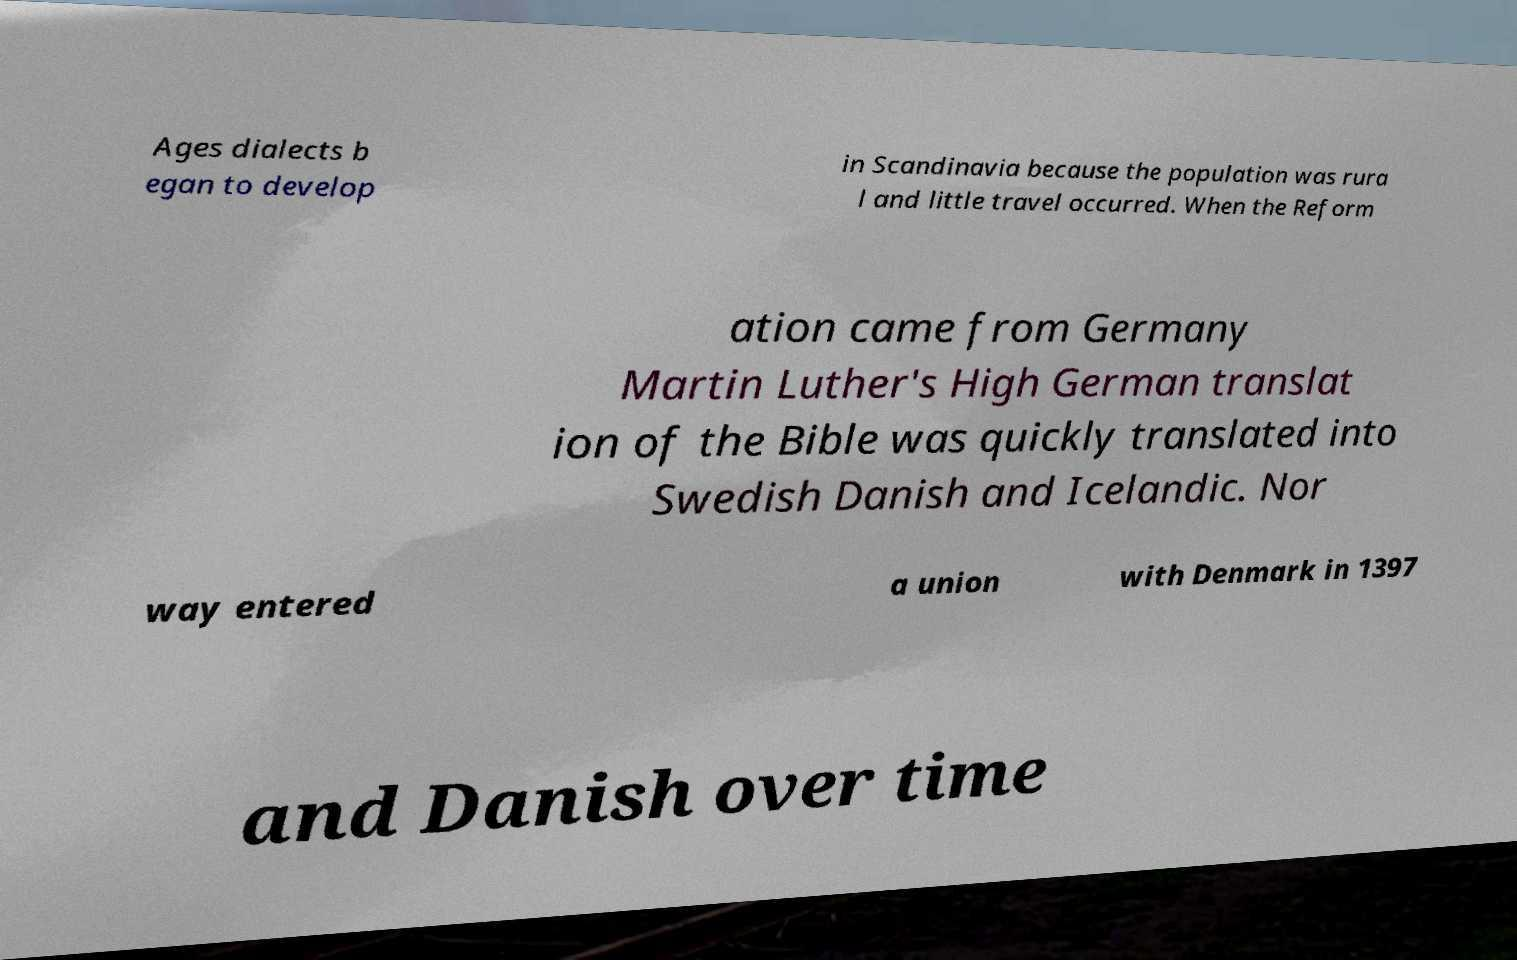Can you read and provide the text displayed in the image?This photo seems to have some interesting text. Can you extract and type it out for me? Ages dialects b egan to develop in Scandinavia because the population was rura l and little travel occurred. When the Reform ation came from Germany Martin Luther's High German translat ion of the Bible was quickly translated into Swedish Danish and Icelandic. Nor way entered a union with Denmark in 1397 and Danish over time 